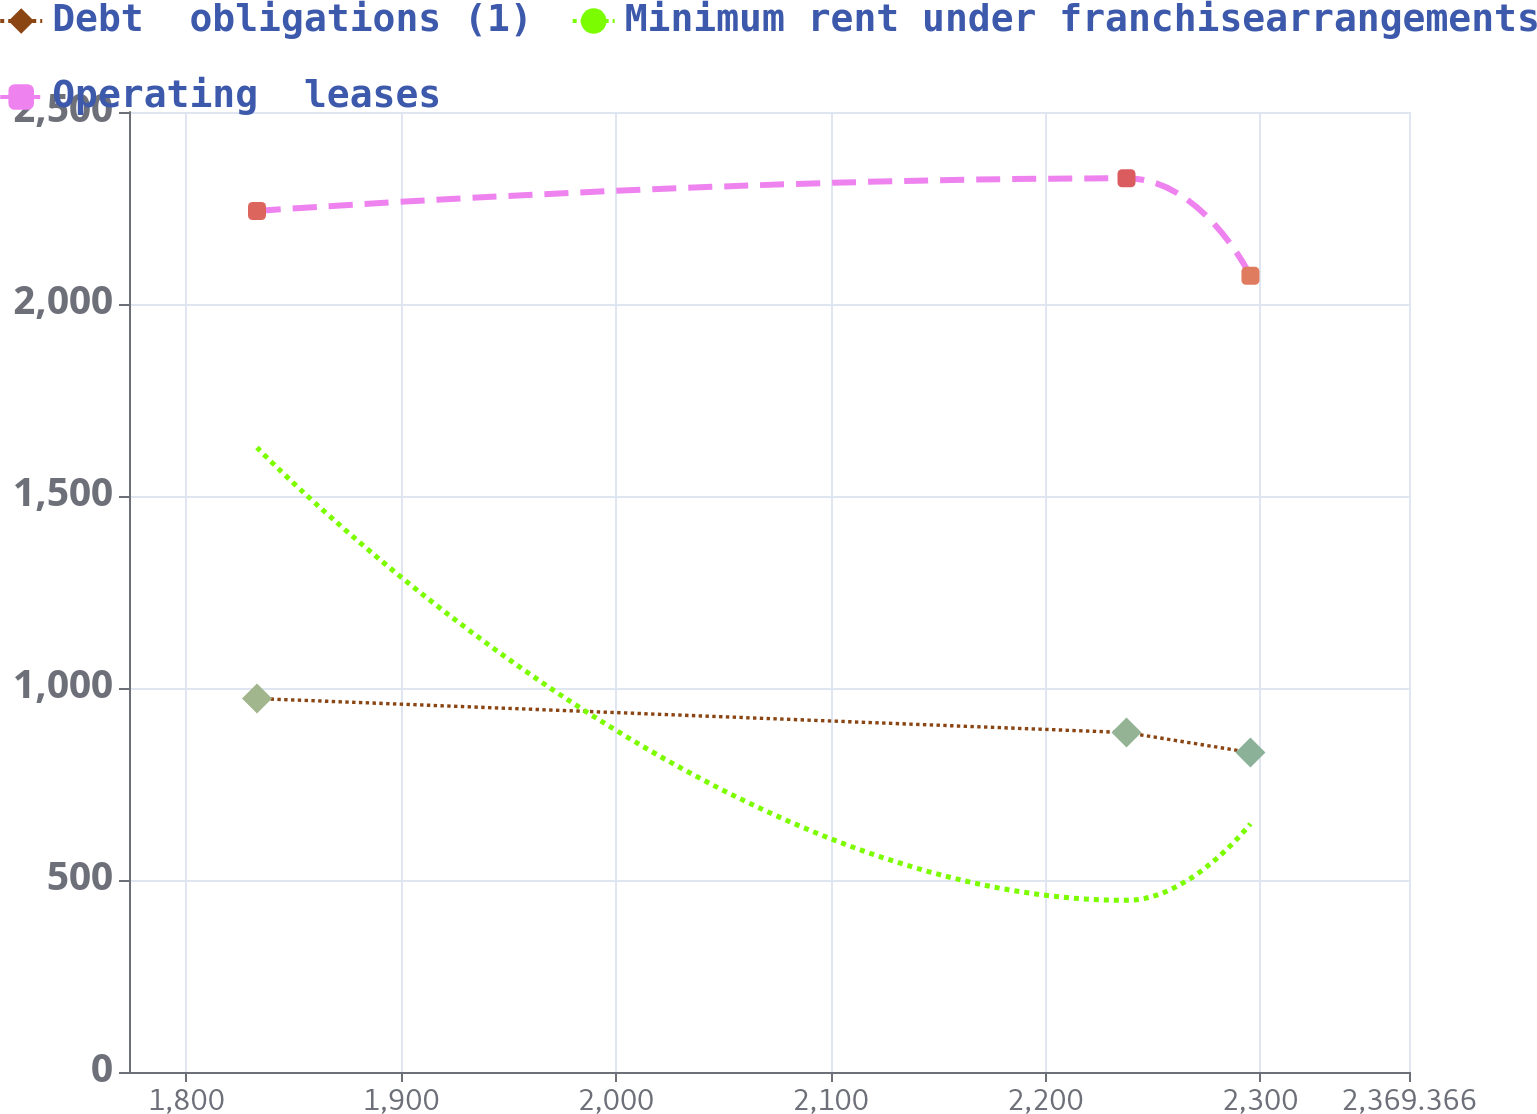Convert chart. <chart><loc_0><loc_0><loc_500><loc_500><line_chart><ecel><fcel>Debt  obligations (1)<fcel>Minimum rent under franchisearrangements<fcel>Operating  leases<nl><fcel>1832.84<fcel>972.59<fcel>1626.17<fcel>2242.25<nl><fcel>2237.8<fcel>883.88<fcel>447<fcel>2327.34<nl><fcel>2295.52<fcel>832.09<fcel>646.68<fcel>2073.25<nl><fcel>2371.26<fcel>816.48<fcel>846.36<fcel>1473.18<nl><fcel>2428.98<fcel>899.49<fcel>2443.8<fcel>1915.46<nl></chart> 